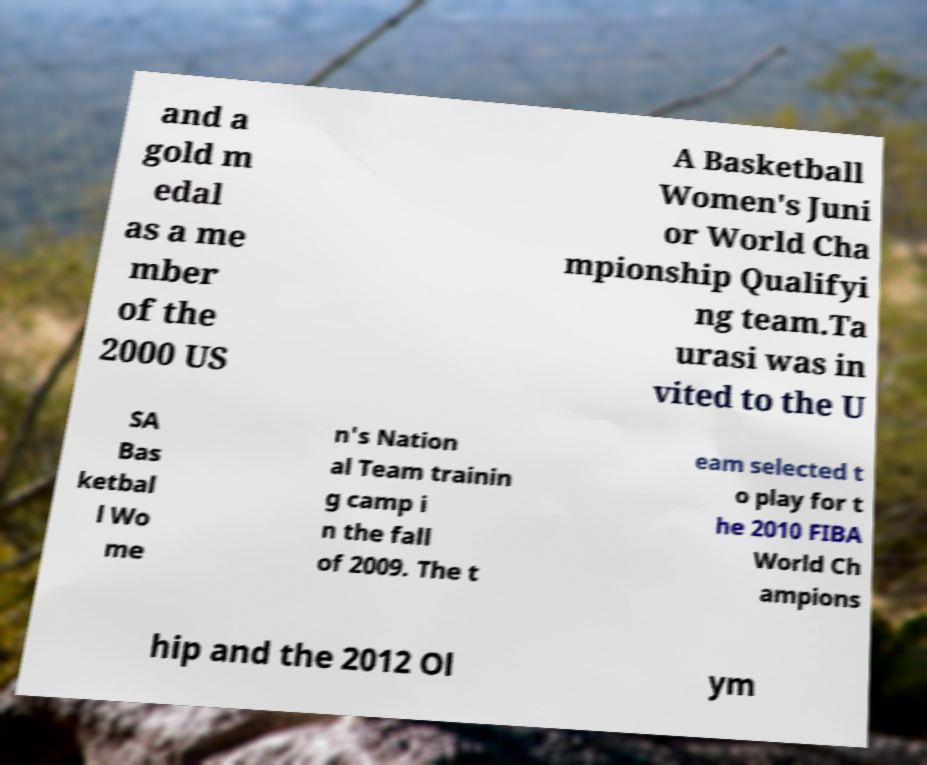Please identify and transcribe the text found in this image. and a gold m edal as a me mber of the 2000 US A Basketball Women's Juni or World Cha mpionship Qualifyi ng team.Ta urasi was in vited to the U SA Bas ketbal l Wo me n's Nation al Team trainin g camp i n the fall of 2009. The t eam selected t o play for t he 2010 FIBA World Ch ampions hip and the 2012 Ol ym 